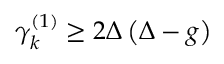<formula> <loc_0><loc_0><loc_500><loc_500>\begin{array} { r } { \gamma _ { k } ^ { ( 1 ) } \geq 2 \Delta \left ( \Delta - g \right ) } \end{array}</formula> 